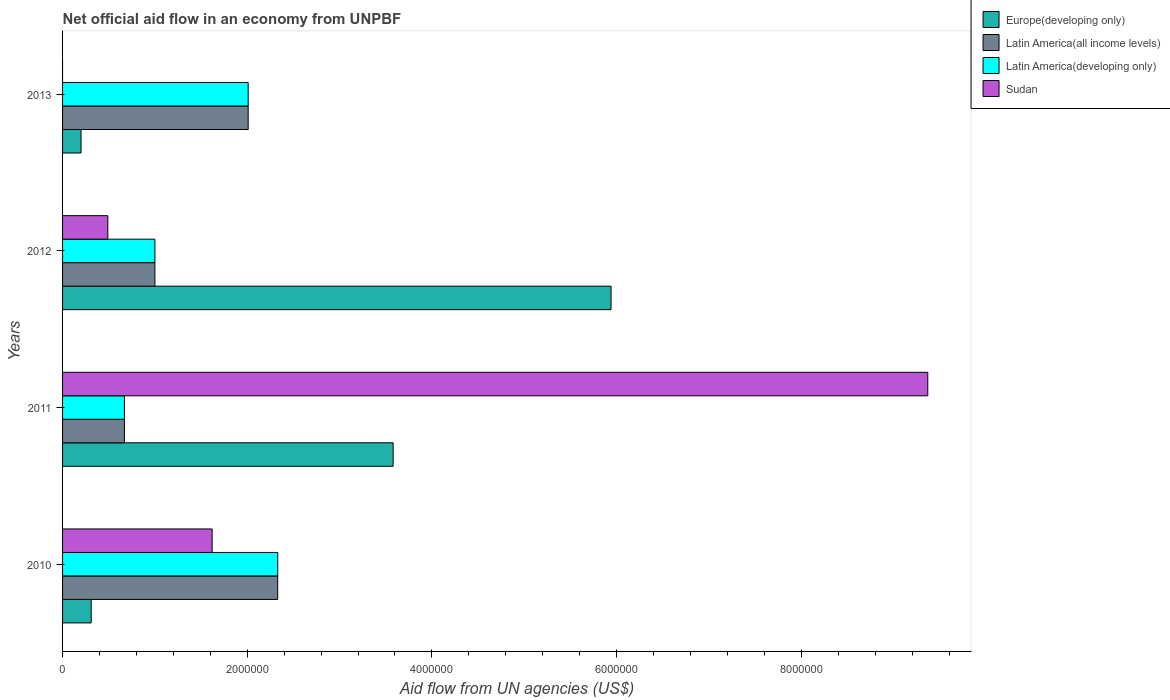How many groups of bars are there?
Ensure brevity in your answer.  4. Are the number of bars per tick equal to the number of legend labels?
Your answer should be very brief. No. Are the number of bars on each tick of the Y-axis equal?
Provide a succinct answer. No. How many bars are there on the 1st tick from the bottom?
Provide a succinct answer. 4. In how many cases, is the number of bars for a given year not equal to the number of legend labels?
Give a very brief answer. 1. What is the net official aid flow in Europe(developing only) in 2013?
Your response must be concise. 2.00e+05. Across all years, what is the maximum net official aid flow in Latin America(developing only)?
Offer a very short reply. 2.33e+06. Across all years, what is the minimum net official aid flow in Latin America(all income levels)?
Ensure brevity in your answer.  6.70e+05. What is the total net official aid flow in Sudan in the graph?
Your answer should be very brief. 1.15e+07. What is the difference between the net official aid flow in Latin America(all income levels) in 2010 and that in 2013?
Your answer should be compact. 3.20e+05. What is the difference between the net official aid flow in Europe(developing only) in 2010 and the net official aid flow in Latin America(developing only) in 2012?
Your answer should be compact. -6.90e+05. What is the average net official aid flow in Latin America(developing only) per year?
Provide a succinct answer. 1.50e+06. In the year 2010, what is the difference between the net official aid flow in Europe(developing only) and net official aid flow in Latin America(developing only)?
Provide a short and direct response. -2.02e+06. In how many years, is the net official aid flow in Latin America(all income levels) greater than 8000000 US$?
Your answer should be very brief. 0. What is the ratio of the net official aid flow in Europe(developing only) in 2010 to that in 2013?
Keep it short and to the point. 1.55. What is the difference between the highest and the second highest net official aid flow in Sudan?
Ensure brevity in your answer.  7.75e+06. What is the difference between the highest and the lowest net official aid flow in Europe(developing only)?
Give a very brief answer. 5.74e+06. Is the sum of the net official aid flow in Latin America(all income levels) in 2010 and 2013 greater than the maximum net official aid flow in Latin America(developing only) across all years?
Keep it short and to the point. Yes. How many bars are there?
Offer a terse response. 15. What is the difference between two consecutive major ticks on the X-axis?
Provide a succinct answer. 2.00e+06. Where does the legend appear in the graph?
Your response must be concise. Top right. How many legend labels are there?
Keep it short and to the point. 4. How are the legend labels stacked?
Provide a short and direct response. Vertical. What is the title of the graph?
Your answer should be compact. Net official aid flow in an economy from UNPBF. What is the label or title of the X-axis?
Your answer should be very brief. Aid flow from UN agencies (US$). What is the label or title of the Y-axis?
Offer a very short reply. Years. What is the Aid flow from UN agencies (US$) in Latin America(all income levels) in 2010?
Your answer should be compact. 2.33e+06. What is the Aid flow from UN agencies (US$) of Latin America(developing only) in 2010?
Provide a short and direct response. 2.33e+06. What is the Aid flow from UN agencies (US$) in Sudan in 2010?
Your answer should be compact. 1.62e+06. What is the Aid flow from UN agencies (US$) of Europe(developing only) in 2011?
Your answer should be very brief. 3.58e+06. What is the Aid flow from UN agencies (US$) of Latin America(all income levels) in 2011?
Offer a very short reply. 6.70e+05. What is the Aid flow from UN agencies (US$) in Latin America(developing only) in 2011?
Ensure brevity in your answer.  6.70e+05. What is the Aid flow from UN agencies (US$) in Sudan in 2011?
Your answer should be very brief. 9.37e+06. What is the Aid flow from UN agencies (US$) in Europe(developing only) in 2012?
Your answer should be compact. 5.94e+06. What is the Aid flow from UN agencies (US$) of Latin America(all income levels) in 2012?
Provide a succinct answer. 1.00e+06. What is the Aid flow from UN agencies (US$) in Latin America(all income levels) in 2013?
Your answer should be very brief. 2.01e+06. What is the Aid flow from UN agencies (US$) of Latin America(developing only) in 2013?
Your response must be concise. 2.01e+06. What is the Aid flow from UN agencies (US$) in Sudan in 2013?
Provide a short and direct response. 0. Across all years, what is the maximum Aid flow from UN agencies (US$) of Europe(developing only)?
Keep it short and to the point. 5.94e+06. Across all years, what is the maximum Aid flow from UN agencies (US$) of Latin America(all income levels)?
Provide a short and direct response. 2.33e+06. Across all years, what is the maximum Aid flow from UN agencies (US$) in Latin America(developing only)?
Provide a succinct answer. 2.33e+06. Across all years, what is the maximum Aid flow from UN agencies (US$) in Sudan?
Offer a very short reply. 9.37e+06. Across all years, what is the minimum Aid flow from UN agencies (US$) of Europe(developing only)?
Your answer should be very brief. 2.00e+05. Across all years, what is the minimum Aid flow from UN agencies (US$) of Latin America(all income levels)?
Your response must be concise. 6.70e+05. Across all years, what is the minimum Aid flow from UN agencies (US$) of Latin America(developing only)?
Give a very brief answer. 6.70e+05. Across all years, what is the minimum Aid flow from UN agencies (US$) in Sudan?
Make the answer very short. 0. What is the total Aid flow from UN agencies (US$) in Europe(developing only) in the graph?
Provide a short and direct response. 1.00e+07. What is the total Aid flow from UN agencies (US$) of Latin America(all income levels) in the graph?
Give a very brief answer. 6.01e+06. What is the total Aid flow from UN agencies (US$) of Latin America(developing only) in the graph?
Give a very brief answer. 6.01e+06. What is the total Aid flow from UN agencies (US$) of Sudan in the graph?
Your answer should be compact. 1.15e+07. What is the difference between the Aid flow from UN agencies (US$) in Europe(developing only) in 2010 and that in 2011?
Provide a short and direct response. -3.27e+06. What is the difference between the Aid flow from UN agencies (US$) in Latin America(all income levels) in 2010 and that in 2011?
Make the answer very short. 1.66e+06. What is the difference between the Aid flow from UN agencies (US$) of Latin America(developing only) in 2010 and that in 2011?
Your response must be concise. 1.66e+06. What is the difference between the Aid flow from UN agencies (US$) in Sudan in 2010 and that in 2011?
Keep it short and to the point. -7.75e+06. What is the difference between the Aid flow from UN agencies (US$) of Europe(developing only) in 2010 and that in 2012?
Provide a succinct answer. -5.63e+06. What is the difference between the Aid flow from UN agencies (US$) of Latin America(all income levels) in 2010 and that in 2012?
Provide a short and direct response. 1.33e+06. What is the difference between the Aid flow from UN agencies (US$) in Latin America(developing only) in 2010 and that in 2012?
Give a very brief answer. 1.33e+06. What is the difference between the Aid flow from UN agencies (US$) of Sudan in 2010 and that in 2012?
Ensure brevity in your answer.  1.13e+06. What is the difference between the Aid flow from UN agencies (US$) in Europe(developing only) in 2010 and that in 2013?
Offer a terse response. 1.10e+05. What is the difference between the Aid flow from UN agencies (US$) in Latin America(all income levels) in 2010 and that in 2013?
Your answer should be compact. 3.20e+05. What is the difference between the Aid flow from UN agencies (US$) in Europe(developing only) in 2011 and that in 2012?
Your answer should be very brief. -2.36e+06. What is the difference between the Aid flow from UN agencies (US$) of Latin America(all income levels) in 2011 and that in 2012?
Provide a succinct answer. -3.30e+05. What is the difference between the Aid flow from UN agencies (US$) in Latin America(developing only) in 2011 and that in 2012?
Provide a succinct answer. -3.30e+05. What is the difference between the Aid flow from UN agencies (US$) in Sudan in 2011 and that in 2012?
Keep it short and to the point. 8.88e+06. What is the difference between the Aid flow from UN agencies (US$) of Europe(developing only) in 2011 and that in 2013?
Your answer should be compact. 3.38e+06. What is the difference between the Aid flow from UN agencies (US$) in Latin America(all income levels) in 2011 and that in 2013?
Give a very brief answer. -1.34e+06. What is the difference between the Aid flow from UN agencies (US$) in Latin America(developing only) in 2011 and that in 2013?
Provide a short and direct response. -1.34e+06. What is the difference between the Aid flow from UN agencies (US$) in Europe(developing only) in 2012 and that in 2013?
Offer a very short reply. 5.74e+06. What is the difference between the Aid flow from UN agencies (US$) of Latin America(all income levels) in 2012 and that in 2013?
Give a very brief answer. -1.01e+06. What is the difference between the Aid flow from UN agencies (US$) of Latin America(developing only) in 2012 and that in 2013?
Your response must be concise. -1.01e+06. What is the difference between the Aid flow from UN agencies (US$) of Europe(developing only) in 2010 and the Aid flow from UN agencies (US$) of Latin America(all income levels) in 2011?
Give a very brief answer. -3.60e+05. What is the difference between the Aid flow from UN agencies (US$) of Europe(developing only) in 2010 and the Aid flow from UN agencies (US$) of Latin America(developing only) in 2011?
Offer a terse response. -3.60e+05. What is the difference between the Aid flow from UN agencies (US$) of Europe(developing only) in 2010 and the Aid flow from UN agencies (US$) of Sudan in 2011?
Your answer should be very brief. -9.06e+06. What is the difference between the Aid flow from UN agencies (US$) in Latin America(all income levels) in 2010 and the Aid flow from UN agencies (US$) in Latin America(developing only) in 2011?
Your response must be concise. 1.66e+06. What is the difference between the Aid flow from UN agencies (US$) of Latin America(all income levels) in 2010 and the Aid flow from UN agencies (US$) of Sudan in 2011?
Keep it short and to the point. -7.04e+06. What is the difference between the Aid flow from UN agencies (US$) in Latin America(developing only) in 2010 and the Aid flow from UN agencies (US$) in Sudan in 2011?
Make the answer very short. -7.04e+06. What is the difference between the Aid flow from UN agencies (US$) of Europe(developing only) in 2010 and the Aid flow from UN agencies (US$) of Latin America(all income levels) in 2012?
Provide a short and direct response. -6.90e+05. What is the difference between the Aid flow from UN agencies (US$) of Europe(developing only) in 2010 and the Aid flow from UN agencies (US$) of Latin America(developing only) in 2012?
Offer a very short reply. -6.90e+05. What is the difference between the Aid flow from UN agencies (US$) in Latin America(all income levels) in 2010 and the Aid flow from UN agencies (US$) in Latin America(developing only) in 2012?
Your response must be concise. 1.33e+06. What is the difference between the Aid flow from UN agencies (US$) in Latin America(all income levels) in 2010 and the Aid flow from UN agencies (US$) in Sudan in 2012?
Your response must be concise. 1.84e+06. What is the difference between the Aid flow from UN agencies (US$) in Latin America(developing only) in 2010 and the Aid flow from UN agencies (US$) in Sudan in 2012?
Provide a succinct answer. 1.84e+06. What is the difference between the Aid flow from UN agencies (US$) of Europe(developing only) in 2010 and the Aid flow from UN agencies (US$) of Latin America(all income levels) in 2013?
Provide a succinct answer. -1.70e+06. What is the difference between the Aid flow from UN agencies (US$) of Europe(developing only) in 2010 and the Aid flow from UN agencies (US$) of Latin America(developing only) in 2013?
Keep it short and to the point. -1.70e+06. What is the difference between the Aid flow from UN agencies (US$) in Latin America(all income levels) in 2010 and the Aid flow from UN agencies (US$) in Latin America(developing only) in 2013?
Make the answer very short. 3.20e+05. What is the difference between the Aid flow from UN agencies (US$) in Europe(developing only) in 2011 and the Aid flow from UN agencies (US$) in Latin America(all income levels) in 2012?
Ensure brevity in your answer.  2.58e+06. What is the difference between the Aid flow from UN agencies (US$) of Europe(developing only) in 2011 and the Aid flow from UN agencies (US$) of Latin America(developing only) in 2012?
Offer a very short reply. 2.58e+06. What is the difference between the Aid flow from UN agencies (US$) in Europe(developing only) in 2011 and the Aid flow from UN agencies (US$) in Sudan in 2012?
Provide a succinct answer. 3.09e+06. What is the difference between the Aid flow from UN agencies (US$) in Latin America(all income levels) in 2011 and the Aid flow from UN agencies (US$) in Latin America(developing only) in 2012?
Provide a short and direct response. -3.30e+05. What is the difference between the Aid flow from UN agencies (US$) in Latin America(all income levels) in 2011 and the Aid flow from UN agencies (US$) in Sudan in 2012?
Keep it short and to the point. 1.80e+05. What is the difference between the Aid flow from UN agencies (US$) in Latin America(developing only) in 2011 and the Aid flow from UN agencies (US$) in Sudan in 2012?
Make the answer very short. 1.80e+05. What is the difference between the Aid flow from UN agencies (US$) of Europe(developing only) in 2011 and the Aid flow from UN agencies (US$) of Latin America(all income levels) in 2013?
Give a very brief answer. 1.57e+06. What is the difference between the Aid flow from UN agencies (US$) of Europe(developing only) in 2011 and the Aid flow from UN agencies (US$) of Latin America(developing only) in 2013?
Ensure brevity in your answer.  1.57e+06. What is the difference between the Aid flow from UN agencies (US$) in Latin America(all income levels) in 2011 and the Aid flow from UN agencies (US$) in Latin America(developing only) in 2013?
Keep it short and to the point. -1.34e+06. What is the difference between the Aid flow from UN agencies (US$) in Europe(developing only) in 2012 and the Aid flow from UN agencies (US$) in Latin America(all income levels) in 2013?
Keep it short and to the point. 3.93e+06. What is the difference between the Aid flow from UN agencies (US$) in Europe(developing only) in 2012 and the Aid flow from UN agencies (US$) in Latin America(developing only) in 2013?
Ensure brevity in your answer.  3.93e+06. What is the difference between the Aid flow from UN agencies (US$) of Latin America(all income levels) in 2012 and the Aid flow from UN agencies (US$) of Latin America(developing only) in 2013?
Provide a succinct answer. -1.01e+06. What is the average Aid flow from UN agencies (US$) in Europe(developing only) per year?
Ensure brevity in your answer.  2.51e+06. What is the average Aid flow from UN agencies (US$) of Latin America(all income levels) per year?
Keep it short and to the point. 1.50e+06. What is the average Aid flow from UN agencies (US$) in Latin America(developing only) per year?
Keep it short and to the point. 1.50e+06. What is the average Aid flow from UN agencies (US$) of Sudan per year?
Ensure brevity in your answer.  2.87e+06. In the year 2010, what is the difference between the Aid flow from UN agencies (US$) in Europe(developing only) and Aid flow from UN agencies (US$) in Latin America(all income levels)?
Provide a short and direct response. -2.02e+06. In the year 2010, what is the difference between the Aid flow from UN agencies (US$) of Europe(developing only) and Aid flow from UN agencies (US$) of Latin America(developing only)?
Provide a succinct answer. -2.02e+06. In the year 2010, what is the difference between the Aid flow from UN agencies (US$) in Europe(developing only) and Aid flow from UN agencies (US$) in Sudan?
Ensure brevity in your answer.  -1.31e+06. In the year 2010, what is the difference between the Aid flow from UN agencies (US$) in Latin America(all income levels) and Aid flow from UN agencies (US$) in Sudan?
Your response must be concise. 7.10e+05. In the year 2010, what is the difference between the Aid flow from UN agencies (US$) in Latin America(developing only) and Aid flow from UN agencies (US$) in Sudan?
Give a very brief answer. 7.10e+05. In the year 2011, what is the difference between the Aid flow from UN agencies (US$) of Europe(developing only) and Aid flow from UN agencies (US$) of Latin America(all income levels)?
Make the answer very short. 2.91e+06. In the year 2011, what is the difference between the Aid flow from UN agencies (US$) in Europe(developing only) and Aid flow from UN agencies (US$) in Latin America(developing only)?
Provide a succinct answer. 2.91e+06. In the year 2011, what is the difference between the Aid flow from UN agencies (US$) in Europe(developing only) and Aid flow from UN agencies (US$) in Sudan?
Give a very brief answer. -5.79e+06. In the year 2011, what is the difference between the Aid flow from UN agencies (US$) of Latin America(all income levels) and Aid flow from UN agencies (US$) of Latin America(developing only)?
Give a very brief answer. 0. In the year 2011, what is the difference between the Aid flow from UN agencies (US$) in Latin America(all income levels) and Aid flow from UN agencies (US$) in Sudan?
Provide a succinct answer. -8.70e+06. In the year 2011, what is the difference between the Aid flow from UN agencies (US$) of Latin America(developing only) and Aid flow from UN agencies (US$) of Sudan?
Give a very brief answer. -8.70e+06. In the year 2012, what is the difference between the Aid flow from UN agencies (US$) in Europe(developing only) and Aid flow from UN agencies (US$) in Latin America(all income levels)?
Your answer should be very brief. 4.94e+06. In the year 2012, what is the difference between the Aid flow from UN agencies (US$) in Europe(developing only) and Aid flow from UN agencies (US$) in Latin America(developing only)?
Ensure brevity in your answer.  4.94e+06. In the year 2012, what is the difference between the Aid flow from UN agencies (US$) in Europe(developing only) and Aid flow from UN agencies (US$) in Sudan?
Provide a short and direct response. 5.45e+06. In the year 2012, what is the difference between the Aid flow from UN agencies (US$) in Latin America(all income levels) and Aid flow from UN agencies (US$) in Latin America(developing only)?
Give a very brief answer. 0. In the year 2012, what is the difference between the Aid flow from UN agencies (US$) of Latin America(all income levels) and Aid flow from UN agencies (US$) of Sudan?
Give a very brief answer. 5.10e+05. In the year 2012, what is the difference between the Aid flow from UN agencies (US$) of Latin America(developing only) and Aid flow from UN agencies (US$) of Sudan?
Provide a succinct answer. 5.10e+05. In the year 2013, what is the difference between the Aid flow from UN agencies (US$) of Europe(developing only) and Aid flow from UN agencies (US$) of Latin America(all income levels)?
Make the answer very short. -1.81e+06. In the year 2013, what is the difference between the Aid flow from UN agencies (US$) of Europe(developing only) and Aid flow from UN agencies (US$) of Latin America(developing only)?
Provide a succinct answer. -1.81e+06. In the year 2013, what is the difference between the Aid flow from UN agencies (US$) in Latin America(all income levels) and Aid flow from UN agencies (US$) in Latin America(developing only)?
Ensure brevity in your answer.  0. What is the ratio of the Aid flow from UN agencies (US$) in Europe(developing only) in 2010 to that in 2011?
Keep it short and to the point. 0.09. What is the ratio of the Aid flow from UN agencies (US$) of Latin America(all income levels) in 2010 to that in 2011?
Give a very brief answer. 3.48. What is the ratio of the Aid flow from UN agencies (US$) in Latin America(developing only) in 2010 to that in 2011?
Give a very brief answer. 3.48. What is the ratio of the Aid flow from UN agencies (US$) in Sudan in 2010 to that in 2011?
Provide a short and direct response. 0.17. What is the ratio of the Aid flow from UN agencies (US$) of Europe(developing only) in 2010 to that in 2012?
Your answer should be compact. 0.05. What is the ratio of the Aid flow from UN agencies (US$) in Latin America(all income levels) in 2010 to that in 2012?
Make the answer very short. 2.33. What is the ratio of the Aid flow from UN agencies (US$) of Latin America(developing only) in 2010 to that in 2012?
Your answer should be very brief. 2.33. What is the ratio of the Aid flow from UN agencies (US$) of Sudan in 2010 to that in 2012?
Your response must be concise. 3.31. What is the ratio of the Aid flow from UN agencies (US$) of Europe(developing only) in 2010 to that in 2013?
Ensure brevity in your answer.  1.55. What is the ratio of the Aid flow from UN agencies (US$) in Latin America(all income levels) in 2010 to that in 2013?
Ensure brevity in your answer.  1.16. What is the ratio of the Aid flow from UN agencies (US$) in Latin America(developing only) in 2010 to that in 2013?
Give a very brief answer. 1.16. What is the ratio of the Aid flow from UN agencies (US$) of Europe(developing only) in 2011 to that in 2012?
Give a very brief answer. 0.6. What is the ratio of the Aid flow from UN agencies (US$) in Latin America(all income levels) in 2011 to that in 2012?
Offer a terse response. 0.67. What is the ratio of the Aid flow from UN agencies (US$) in Latin America(developing only) in 2011 to that in 2012?
Provide a short and direct response. 0.67. What is the ratio of the Aid flow from UN agencies (US$) of Sudan in 2011 to that in 2012?
Your answer should be very brief. 19.12. What is the ratio of the Aid flow from UN agencies (US$) in Latin America(all income levels) in 2011 to that in 2013?
Your response must be concise. 0.33. What is the ratio of the Aid flow from UN agencies (US$) in Latin America(developing only) in 2011 to that in 2013?
Your answer should be compact. 0.33. What is the ratio of the Aid flow from UN agencies (US$) of Europe(developing only) in 2012 to that in 2013?
Your answer should be very brief. 29.7. What is the ratio of the Aid flow from UN agencies (US$) of Latin America(all income levels) in 2012 to that in 2013?
Your answer should be compact. 0.5. What is the ratio of the Aid flow from UN agencies (US$) of Latin America(developing only) in 2012 to that in 2013?
Provide a succinct answer. 0.5. What is the difference between the highest and the second highest Aid flow from UN agencies (US$) in Europe(developing only)?
Provide a short and direct response. 2.36e+06. What is the difference between the highest and the second highest Aid flow from UN agencies (US$) in Latin America(developing only)?
Provide a short and direct response. 3.20e+05. What is the difference between the highest and the second highest Aid flow from UN agencies (US$) of Sudan?
Offer a very short reply. 7.75e+06. What is the difference between the highest and the lowest Aid flow from UN agencies (US$) of Europe(developing only)?
Ensure brevity in your answer.  5.74e+06. What is the difference between the highest and the lowest Aid flow from UN agencies (US$) of Latin America(all income levels)?
Give a very brief answer. 1.66e+06. What is the difference between the highest and the lowest Aid flow from UN agencies (US$) of Latin America(developing only)?
Give a very brief answer. 1.66e+06. What is the difference between the highest and the lowest Aid flow from UN agencies (US$) in Sudan?
Provide a succinct answer. 9.37e+06. 